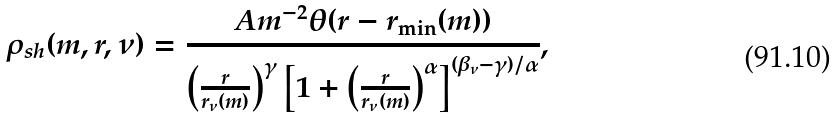<formula> <loc_0><loc_0><loc_500><loc_500>\rho _ { s h } ( m , r , \nu ) = \frac { A m ^ { - 2 } \theta ( r - r _ { \min } ( m ) ) } { \left ( \frac { r } { r _ { \nu } ( m ) } \right ) ^ { \gamma } \left [ 1 + \left ( \frac { r } { r _ { \nu } ( m ) } \right ) ^ { \alpha } \right ] ^ { ( \beta _ { \nu } - \gamma ) / \alpha } } ,</formula> 